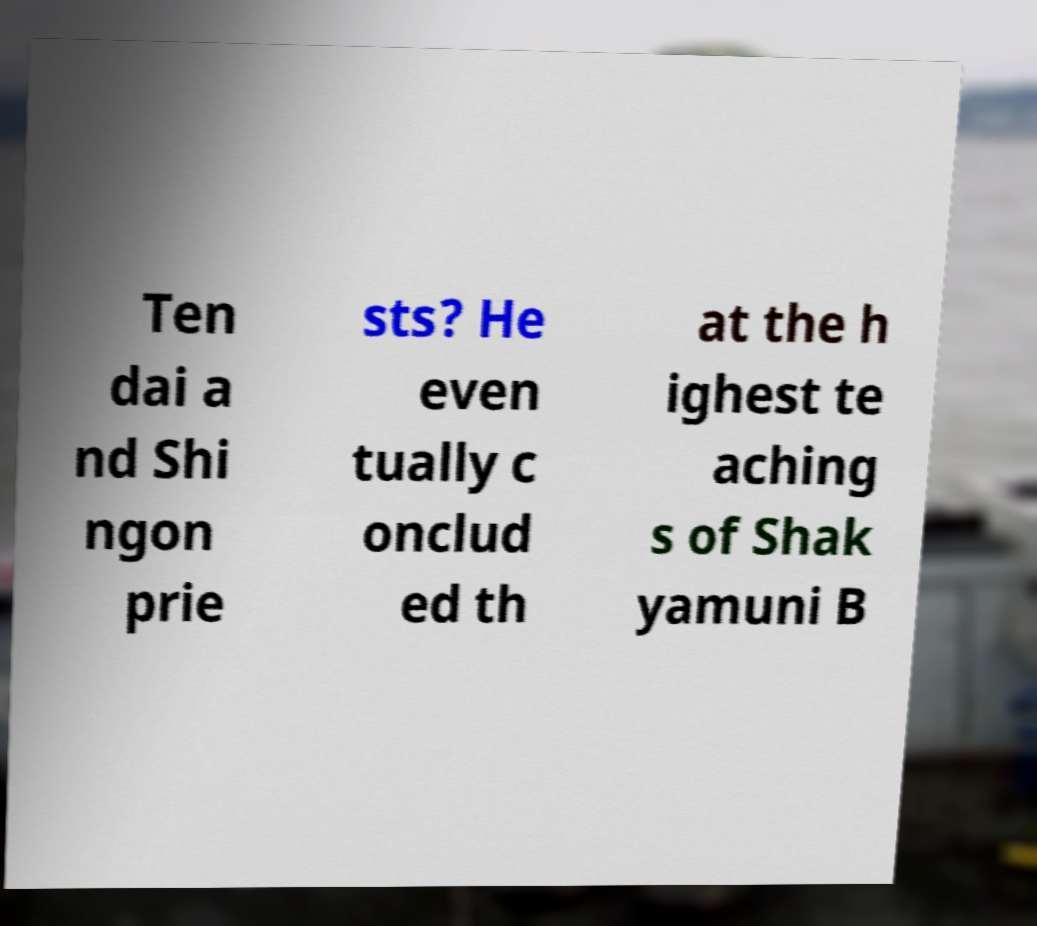What messages or text are displayed in this image? I need them in a readable, typed format. Ten dai a nd Shi ngon prie sts? He even tually c onclud ed th at the h ighest te aching s of Shak yamuni B 